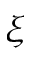<formula> <loc_0><loc_0><loc_500><loc_500>\xi</formula> 